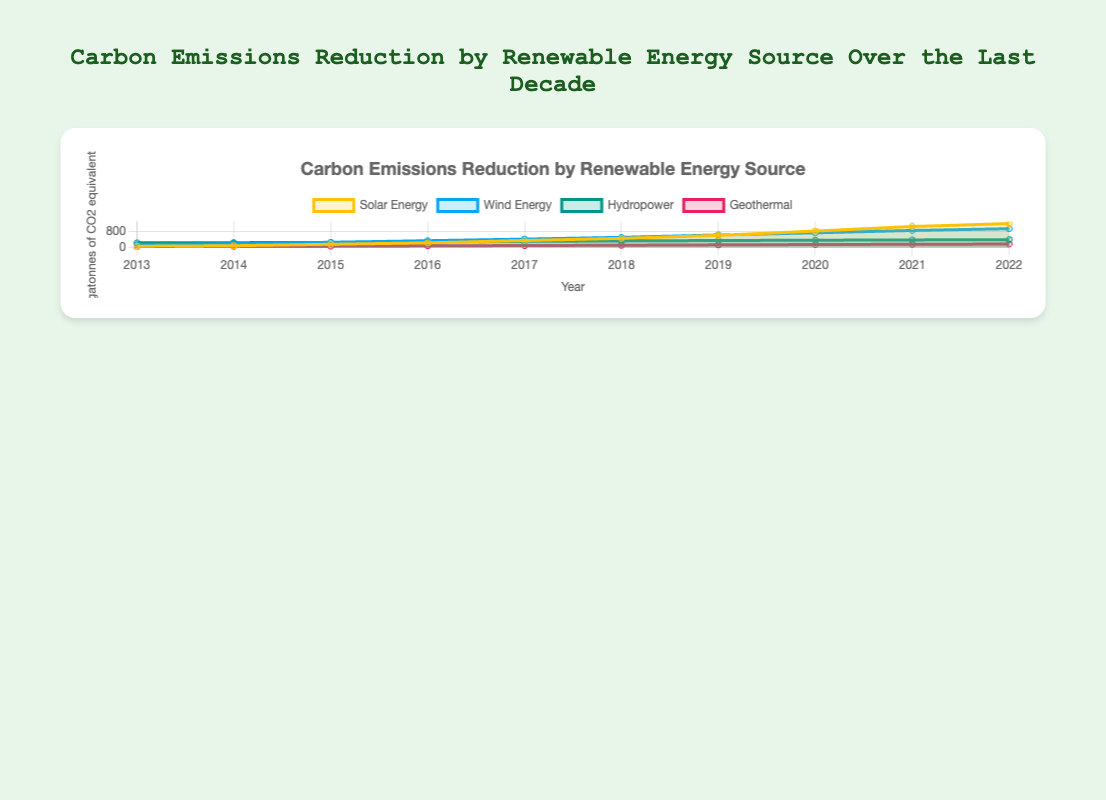What is the title of the figure? The title is displayed at the top of the chart. It reads "Carbon Emissions Reduction by Renewable Energy Source Over the Last Decade".
Answer: Carbon Emissions Reduction by Renewable Energy Source Over the Last Decade What are the units of measurement used on the y-axis? The y-axis label shows the units used, which is "Megatonnes of CO2 equivalent".
Answer: Megatonnes of CO2 equivalent How many energy sources are represented in the chart? The legend at the top of the chart lists the different energy sources. They are Solar Energy, Wind Energy, Hydropower, and Geothermal.
Answer: Four Which energy source had the highest reduction in carbon emissions in 2022? From the areas on the chart related to each energy source, Solar Energy is evidently the highest in 2022.
Answer: Solar Energy By how much did Wind Energy carbon emissions reduction increase from 2013 to 2022? Find the difference between the 2022 and 2013 data points for Wind Energy. Subtract 120 (2013) from 940 (2022).
Answer: 820 Megatonnes Which year did Solar Energy surpass Wind Energy in carbon emissions reduction? By observing the intersection of the areas, we see Solar Energy surpasses Wind Energy between 2018 and 2019.
Answer: Around 2018 What is the total carbon emissions reduction for all energy sources in 2022? Sum the values for 2022 for all energy sources: Solar Energy (1200), Wind Energy (940), Hydropower (385), and Geothermal (160). 1200 + 940 + 385 + 160 = 2685.
Answer: 2685 Megatonnes On average, how much did Geothermal energy reduce carbon emissions annually over the last decade? Find the sum of the Geothermal data points and divide by the number of years. (40 + 45 + 55 + 70 + 85 + 100 + 120 + 135 + 150 + 160) / 10 = 96.
Answer: 96 Megatonnes per year Did Hydropower see a larger increase in carbon emissions reduction from 2013 to 2022 compared to Geothermal? Calculate the increments for both Hydropower and Geothermal over the decade. Hydropower: 385 - 220 = 165. Geothermal: 160 - 40 = 120. Hydropower saw a larger increase.
Answer: Yes Which energy source had the most steady increase in carbon emissions reduction over the last decade? By examining the slope and variation of each area, Hydropower shows the most consistent and steady increase.
Answer: Hydropower 